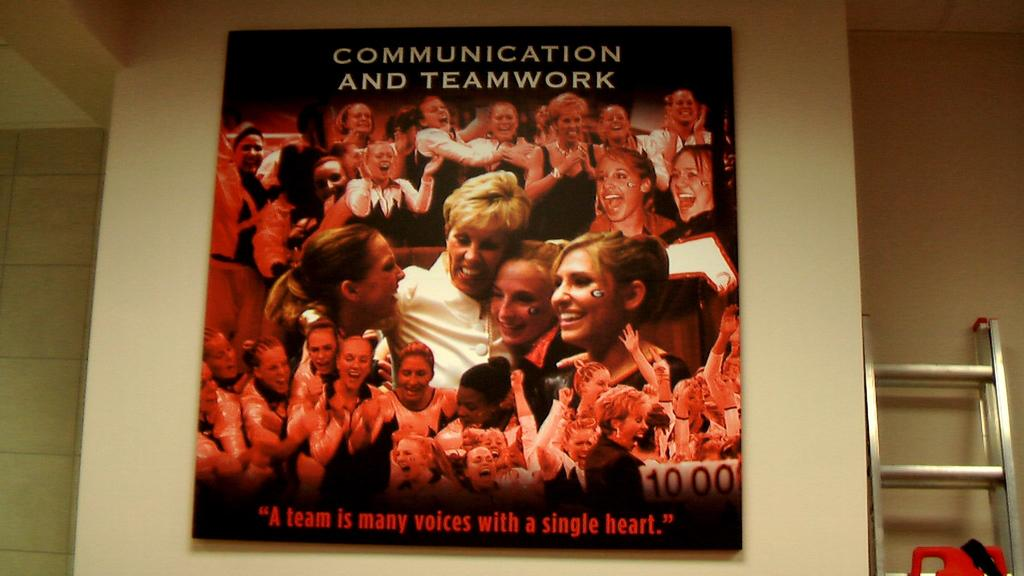<image>
Offer a succinct explanation of the picture presented. A poster depicting numerous faces and many different people is celebrating the concepts of communication and teamwork. 